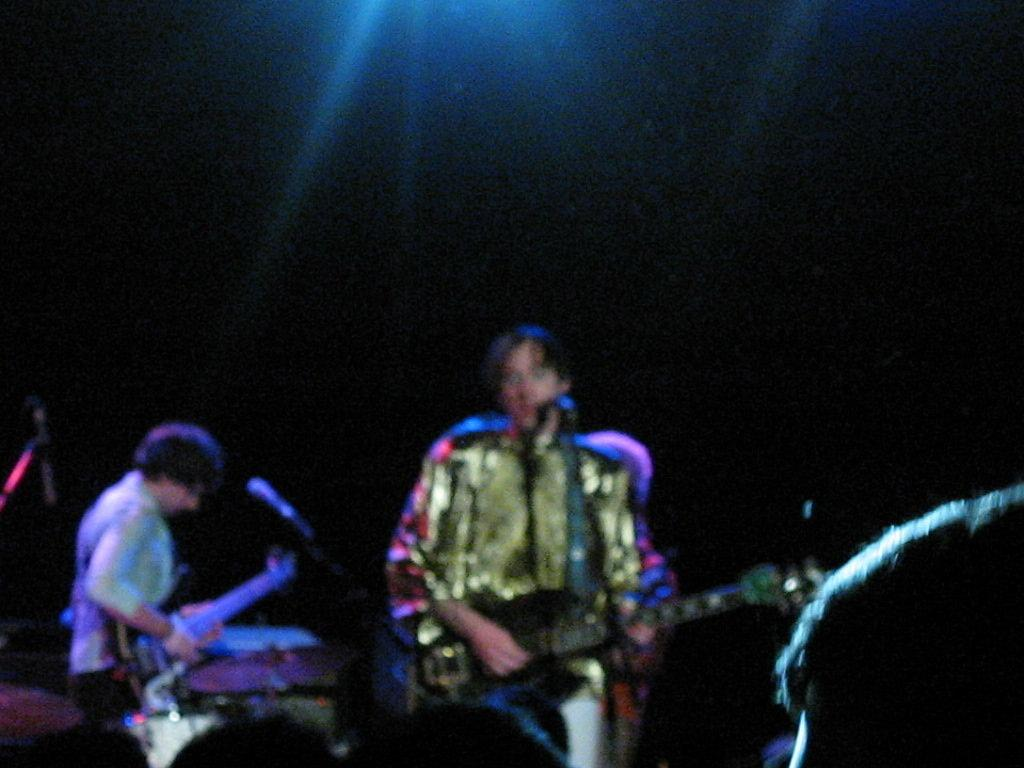How many people are in the image? There are two men in the image. What are the men holding in the image? The men are holding guitars. What object is present for amplifying sound in the image? There is a microphone in the image. What can be observed about the lighting in the image? The background of the image is dark. Can you see a flock of birds flying in the image? There is no flock of birds visible in the image. How many times does the man on the left sneeze in the image? There is no indication of anyone sneezing in the image. 